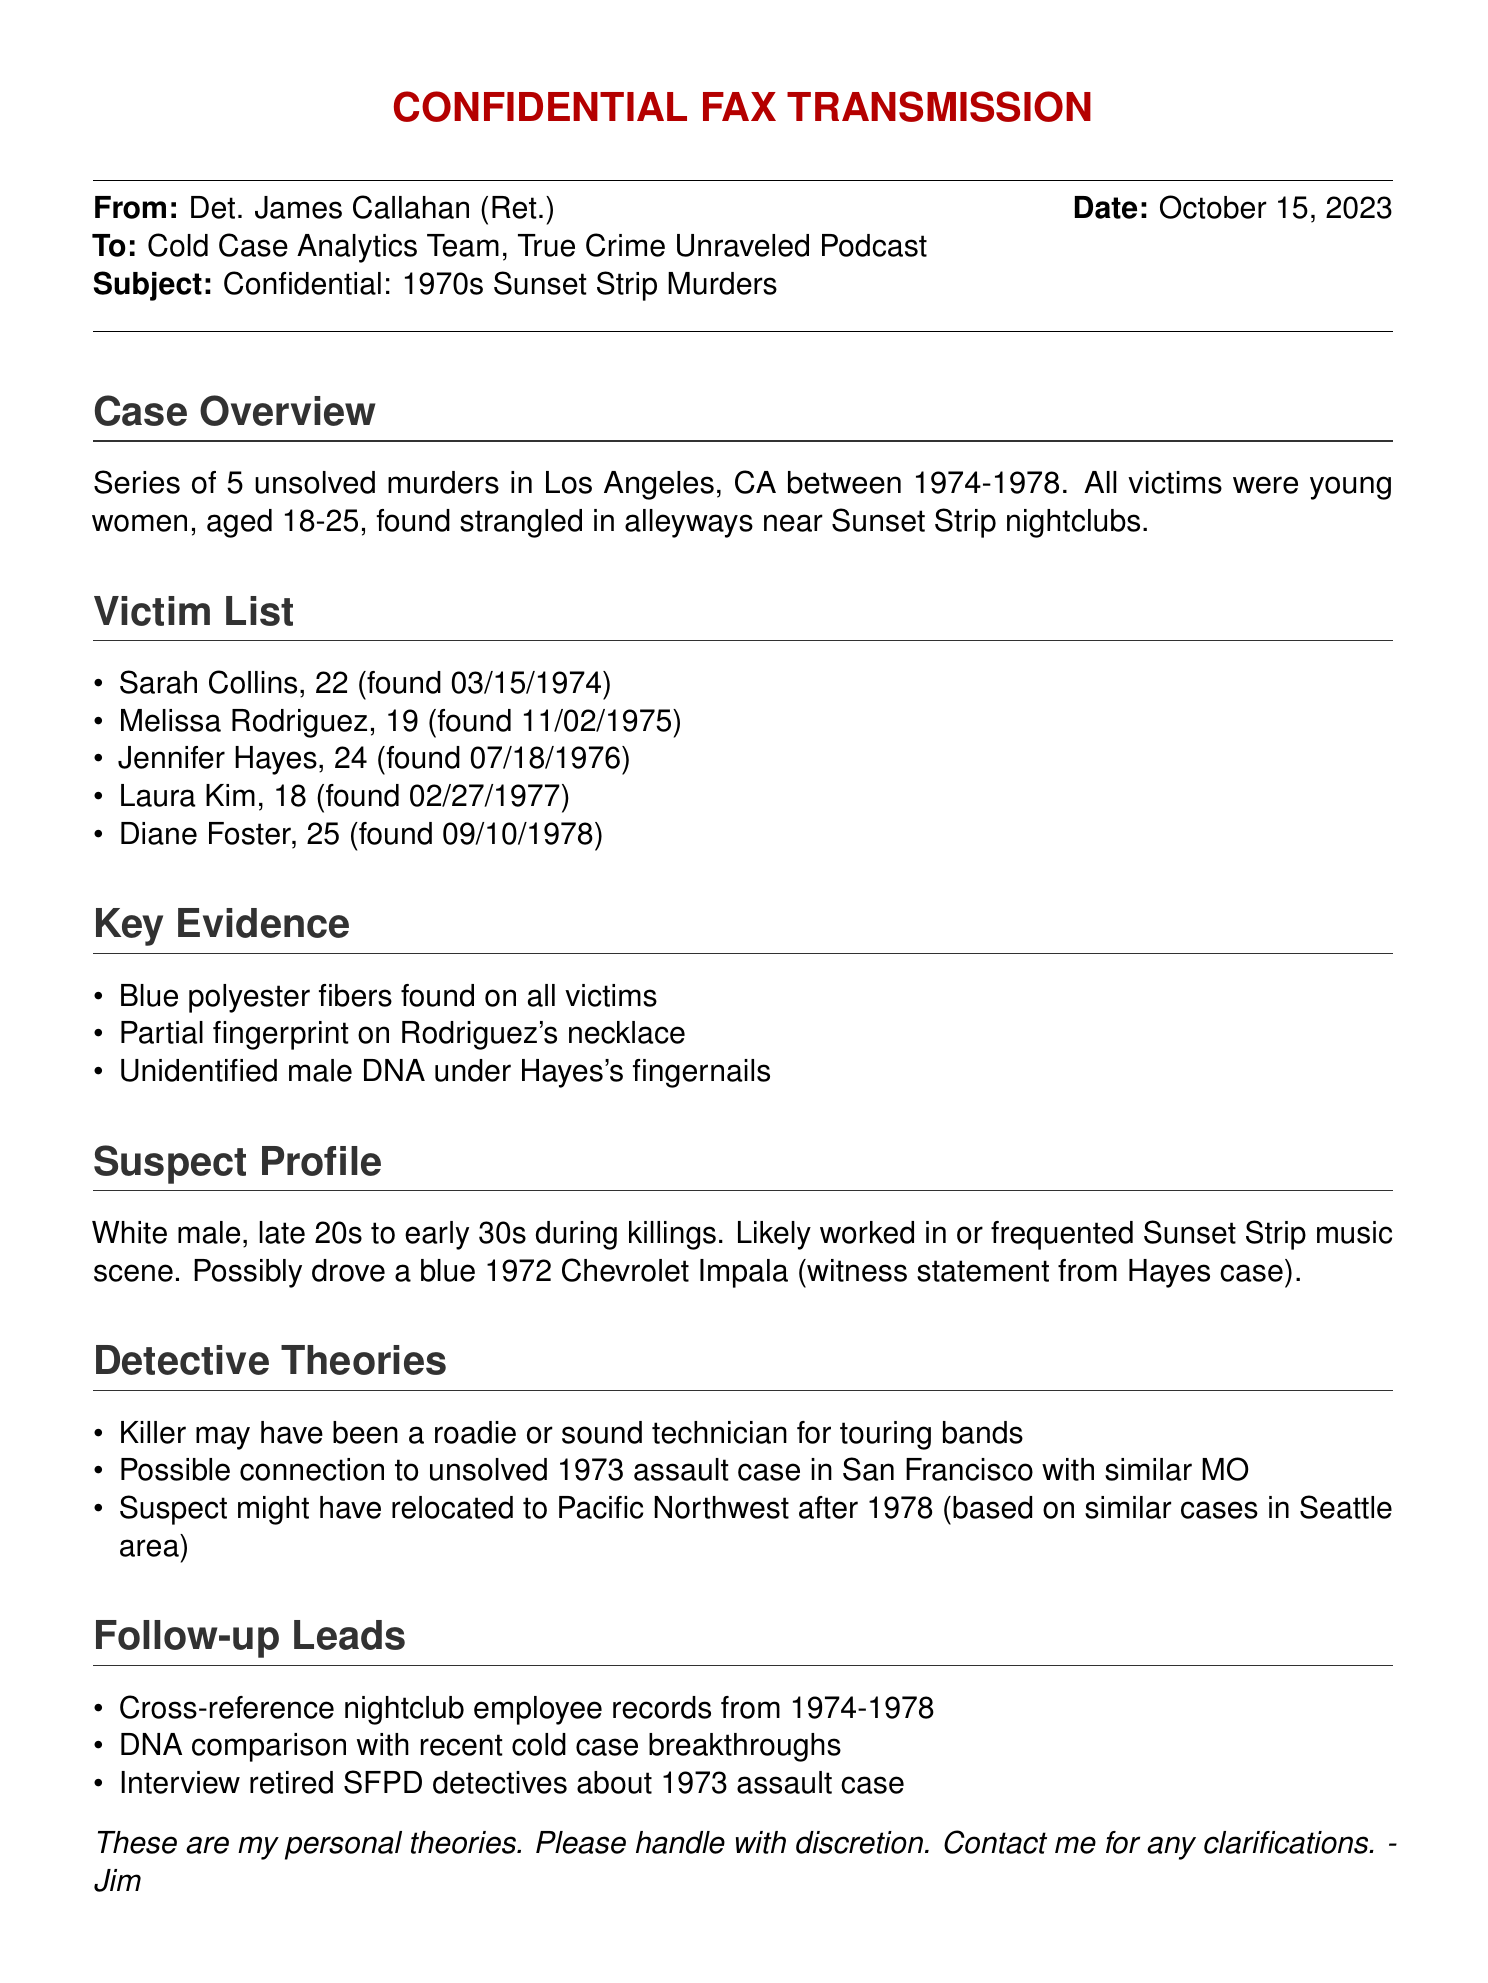What is the date of the fax? The date of the fax is mentioned in the header and is October 15, 2023.
Answer: October 15, 2023 How many victims are listed? The number of victims is found in the victim list section, which details five individuals.
Answer: 5 What was the age range of the victims? The ages of the victims are specified in the victim list, noting they were aged 18 to 25.
Answer: 18-25 What type of car is the suspect possibly associated with? The suspect's vehicle is identified in the suspect profile as a blue 1972 Chevrolet Impala.
Answer: blue 1972 Chevrolet Impala What fibers were found on all victims? The type of fibers found are specified in the key evidence section as blue polyester fibers.
Answer: blue polyester fibers What was one of the detective's theories regarding the suspect's profession? The detective theories mention the possible profession of the suspect as a roadie or sound technician for touring bands.
Answer: roadie or sound technician Which year did the first murder occur? The first murder's date is provided in the victim list, which states March 15, 1974.
Answer: 1974 What kind of DNA evidence was found under Jennifer Hayes's fingernails? The type of DNA evidence is described in the key evidence section as unidentified male DNA.
Answer: unidentified male DNA What should the Cold Case Analytics Team do with the information according to the fax? The fax advises handling the information with discretion, indicating that the content is sensitive and personal.
Answer: handle with discretion 